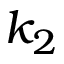Convert formula to latex. <formula><loc_0><loc_0><loc_500><loc_500>k _ { 2 }</formula> 